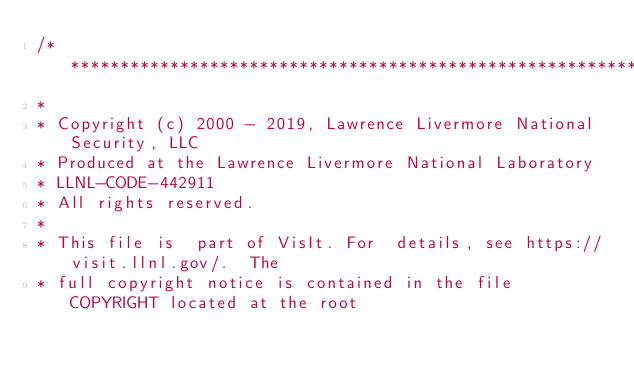<code> <loc_0><loc_0><loc_500><loc_500><_C_>/*****************************************************************************
*
* Copyright (c) 2000 - 2019, Lawrence Livermore National Security, LLC
* Produced at the Lawrence Livermore National Laboratory
* LLNL-CODE-442911
* All rights reserved.
*
* This file is  part of VisIt. For  details, see https://visit.llnl.gov/.  The
* full copyright notice is contained in the file COPYRIGHT located at the root</code> 